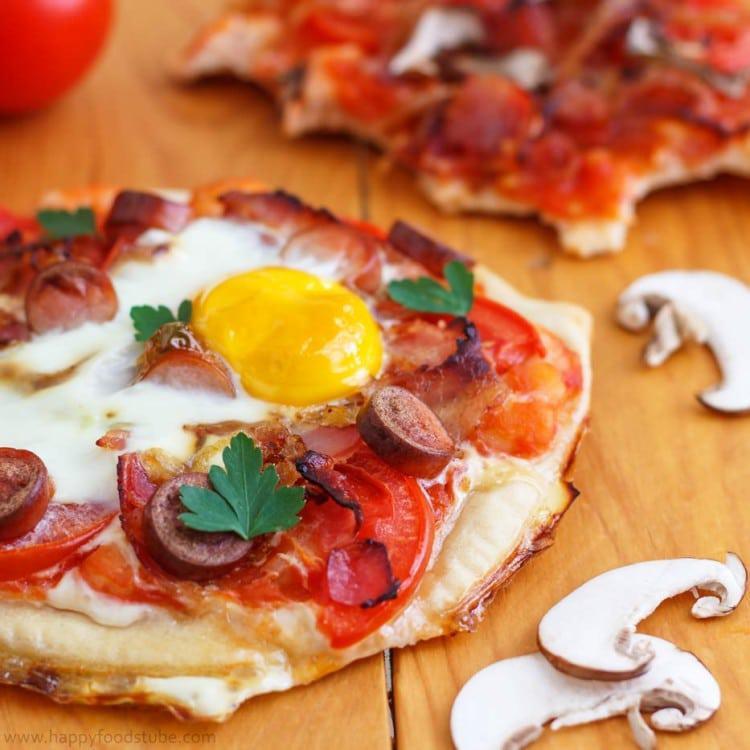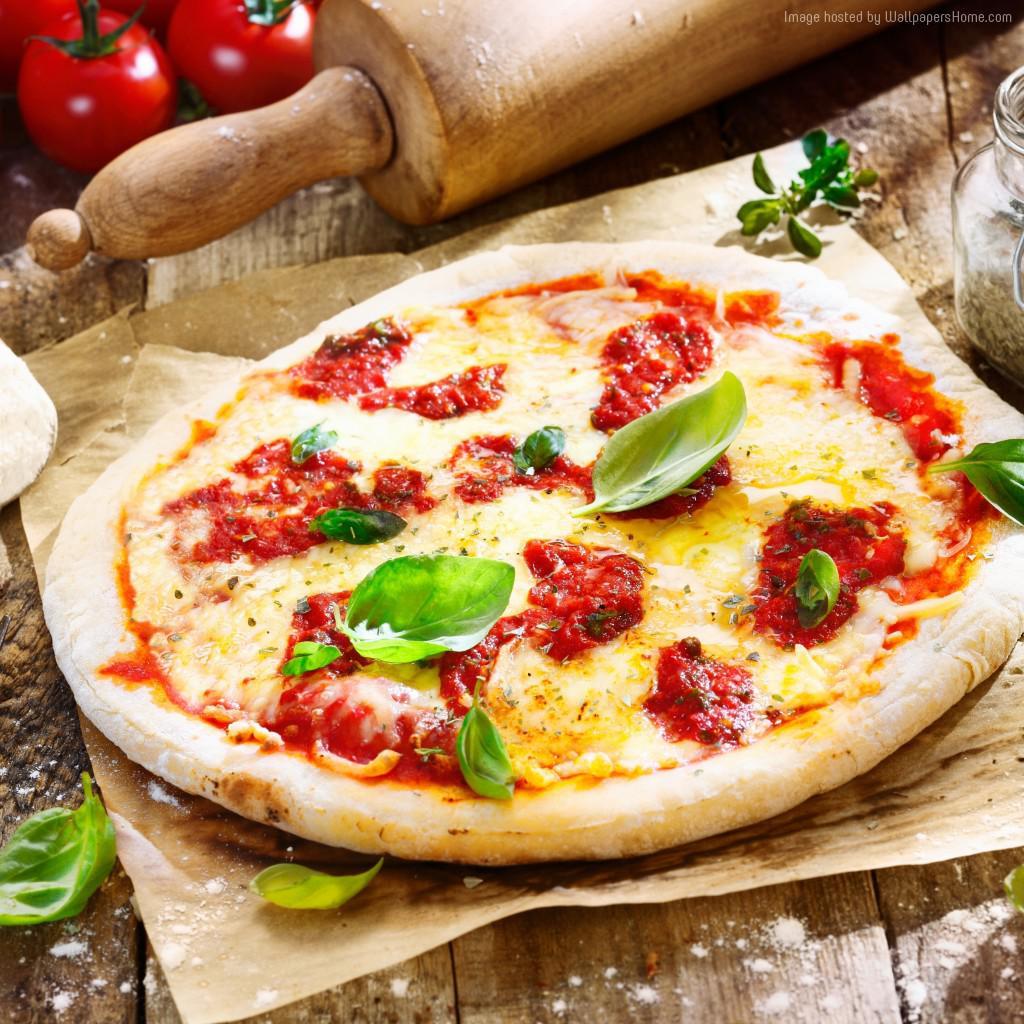The first image is the image on the left, the second image is the image on the right. For the images shown, is this caption "All of the pizzas have been sliced." true? Answer yes or no. No. The first image is the image on the left, the second image is the image on the right. Evaluate the accuracy of this statement regarding the images: "The yellow yolk of an egg and pieces of tomato can be seen among the toppings on a baked pizza in one image". Is it true? Answer yes or no. Yes. 